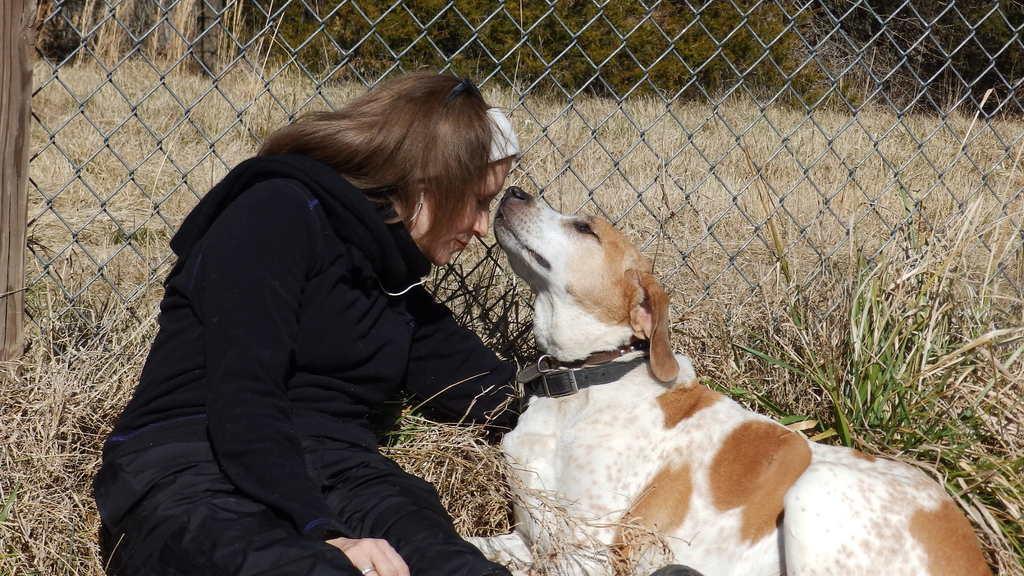Where was the image taken? The image was clicked outside. Who is present in the image? There is a woman in the image. What is the woman wearing? The woman is wearing a black dress. What other living creature is present in the image? There is a dog in the image. How is the dog adorned? The dog has a black belt tied around it. What can be seen in the background of the image? There is dry grass and trees in the background of the image. What type of lipstick is the woman wearing in the image? There is no indication of the woman wearing lipstick in the image. Who is the woman's partner in the image? There is no partner present in the image. 